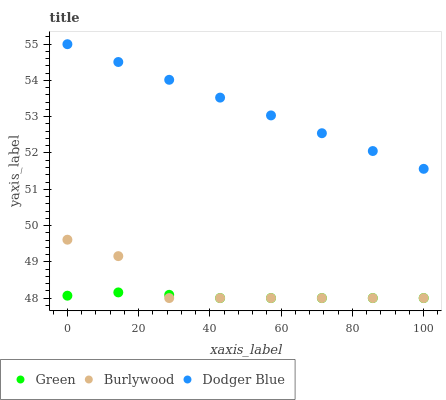Does Green have the minimum area under the curve?
Answer yes or no. Yes. Does Dodger Blue have the maximum area under the curve?
Answer yes or no. Yes. Does Dodger Blue have the minimum area under the curve?
Answer yes or no. No. Does Green have the maximum area under the curve?
Answer yes or no. No. Is Dodger Blue the smoothest?
Answer yes or no. Yes. Is Burlywood the roughest?
Answer yes or no. Yes. Is Green the smoothest?
Answer yes or no. No. Is Green the roughest?
Answer yes or no. No. Does Burlywood have the lowest value?
Answer yes or no. Yes. Does Dodger Blue have the lowest value?
Answer yes or no. No. Does Dodger Blue have the highest value?
Answer yes or no. Yes. Does Green have the highest value?
Answer yes or no. No. Is Green less than Dodger Blue?
Answer yes or no. Yes. Is Dodger Blue greater than Green?
Answer yes or no. Yes. Does Green intersect Burlywood?
Answer yes or no. Yes. Is Green less than Burlywood?
Answer yes or no. No. Is Green greater than Burlywood?
Answer yes or no. No. Does Green intersect Dodger Blue?
Answer yes or no. No. 